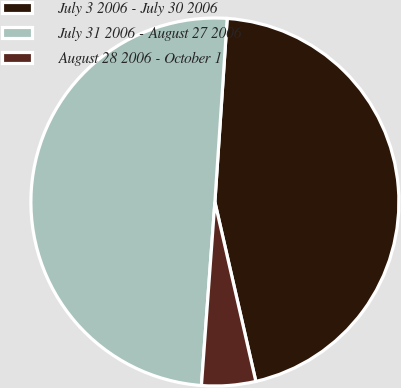Convert chart to OTSL. <chart><loc_0><loc_0><loc_500><loc_500><pie_chart><fcel>July 3 2006 - July 30 2006<fcel>July 31 2006 - August 27 2006<fcel>August 28 2006 - October 1<nl><fcel>45.36%<fcel>49.9%<fcel>4.74%<nl></chart> 